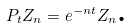<formula> <loc_0><loc_0><loc_500><loc_500>P _ { t } Z _ { n } = e ^ { - n t } Z _ { n } \text {.}</formula> 